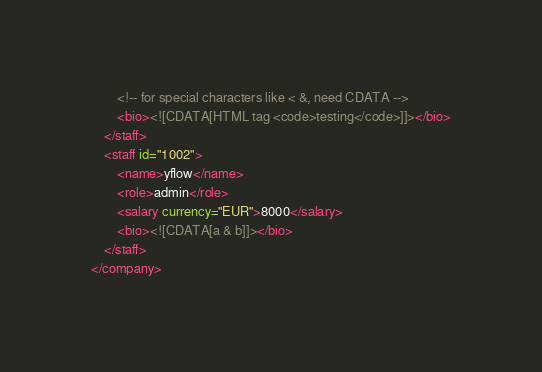<code> <loc_0><loc_0><loc_500><loc_500><_XML_>        <!-- for special characters like < &, need CDATA -->
        <bio><![CDATA[HTML tag <code>testing</code>]]></bio>
    </staff>
    <staff id="1002">
        <name>yflow</name>
        <role>admin</role>
        <salary currency="EUR">8000</salary>
        <bio><![CDATA[a & b]]></bio>
    </staff>
</company></code> 